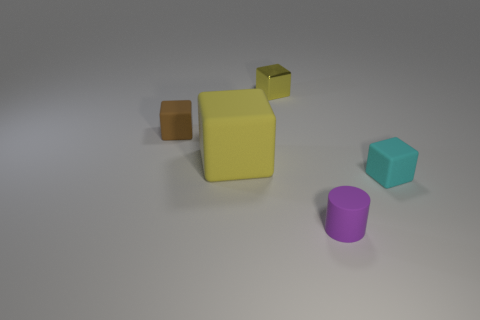Is there any other thing that is the same material as the tiny yellow object?
Give a very brief answer. No. Are there any objects that have the same color as the shiny cube?
Make the answer very short. Yes. Does the block behind the tiny brown block have the same color as the big block that is behind the tiny rubber cylinder?
Ensure brevity in your answer.  Yes. How many objects are big gray cylinders or small matte blocks?
Keep it short and to the point. 2. What is the color of the shiny thing that is the same size as the purple rubber cylinder?
Offer a very short reply. Yellow. What number of things are either blocks to the left of the purple matte cylinder or small brown matte balls?
Provide a short and direct response. 3. What number of other objects are the same size as the matte cylinder?
Make the answer very short. 3. There is a thing that is on the right side of the cylinder; what is its size?
Give a very brief answer. Small. There is a yellow object that is made of the same material as the small brown block; what is its shape?
Ensure brevity in your answer.  Cube. Is there anything else that has the same color as the tiny cylinder?
Provide a short and direct response. No. 